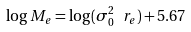Convert formula to latex. <formula><loc_0><loc_0><loc_500><loc_500>\log M _ { e } = \log ( \sigma _ { 0 } ^ { 2 } \ r _ { e } ) + 5 . 6 7</formula> 